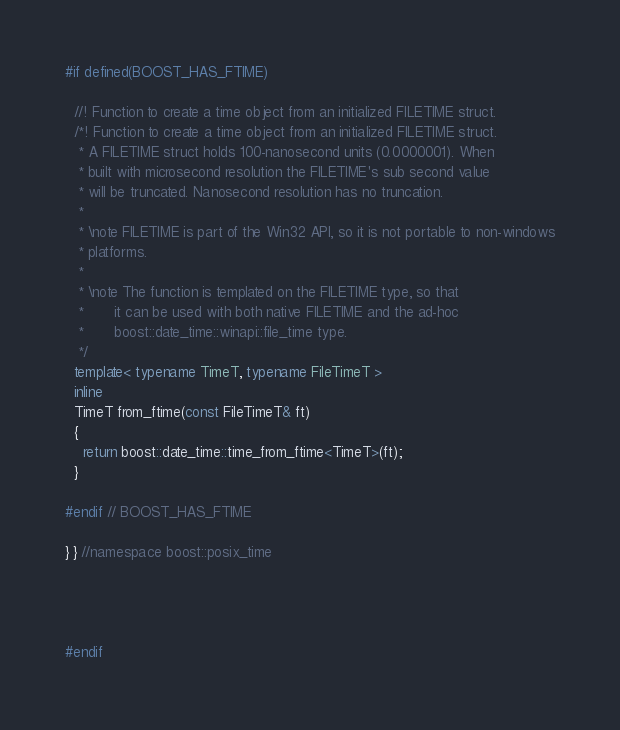<code> <loc_0><loc_0><loc_500><loc_500><_C++_>
#if defined(BOOST_HAS_FTIME)

  //! Function to create a time object from an initialized FILETIME struct.
  /*! Function to create a time object from an initialized FILETIME struct.
   * A FILETIME struct holds 100-nanosecond units (0.0000001). When
   * built with microsecond resolution the FILETIME's sub second value
   * will be truncated. Nanosecond resolution has no truncation.
   *
   * \note FILETIME is part of the Win32 API, so it is not portable to non-windows
   * platforms.
   *
   * \note The function is templated on the FILETIME type, so that
   *       it can be used with both native FILETIME and the ad-hoc
   *       boost::date_time::winapi::file_time type.
   */
  template< typename TimeT, typename FileTimeT >
  inline
  TimeT from_ftime(const FileTimeT& ft)
  {
    return boost::date_time::time_from_ftime<TimeT>(ft);
  }

#endif // BOOST_HAS_FTIME

} } //namespace boost::posix_time




#endif

</code> 